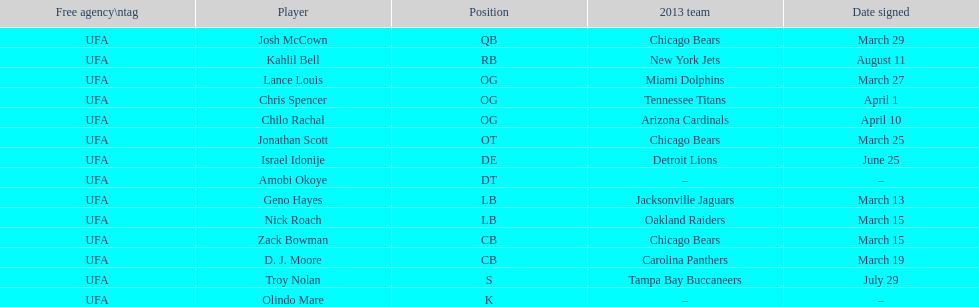The only player to sign in july? Troy Nolan. 